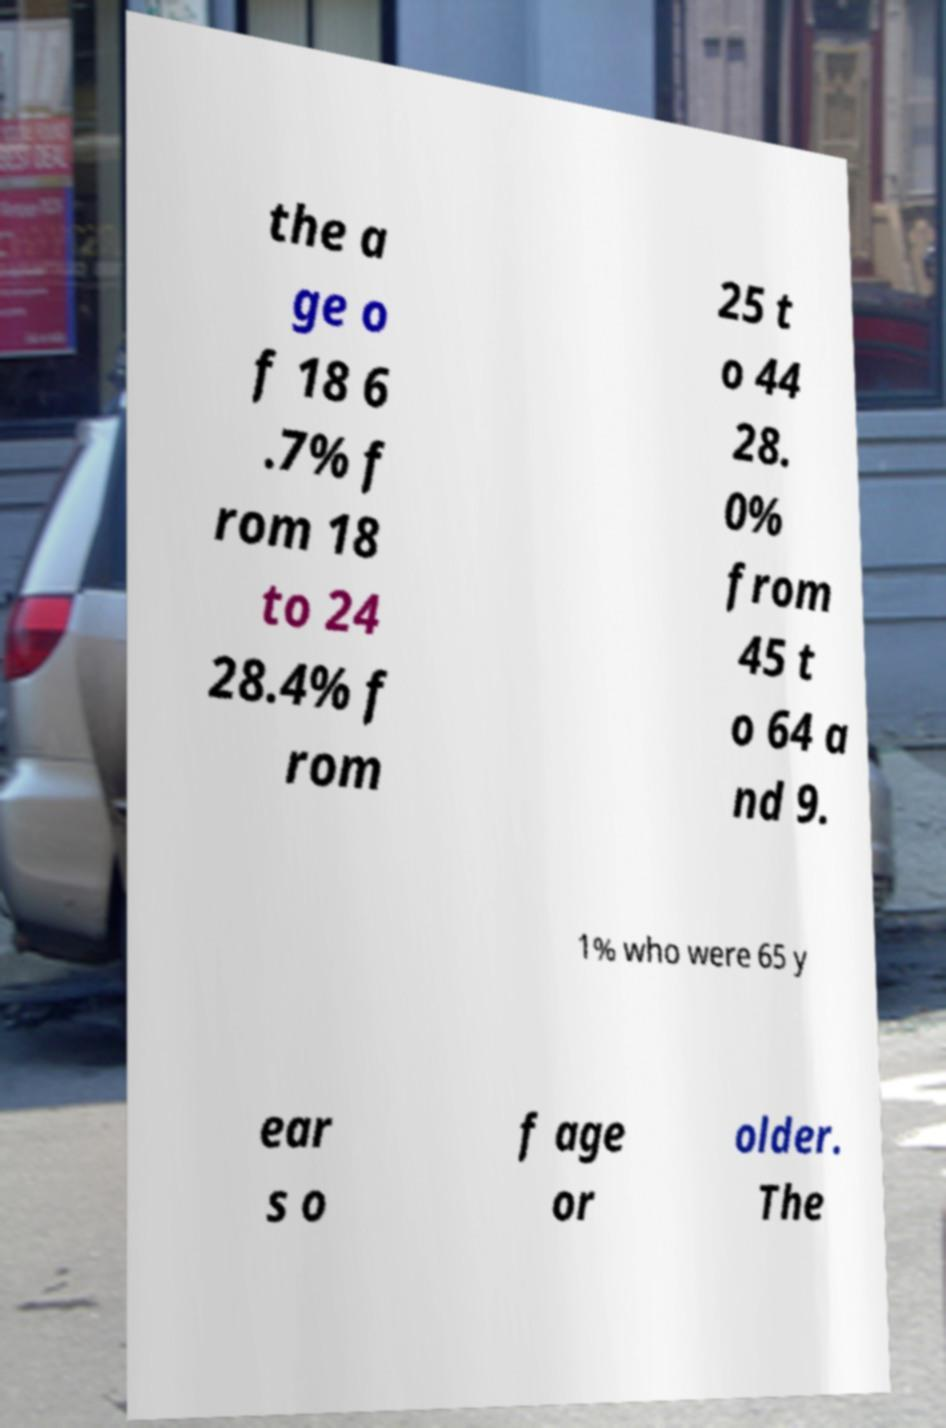Please identify and transcribe the text found in this image. the a ge o f 18 6 .7% f rom 18 to 24 28.4% f rom 25 t o 44 28. 0% from 45 t o 64 a nd 9. 1% who were 65 y ear s o f age or older. The 